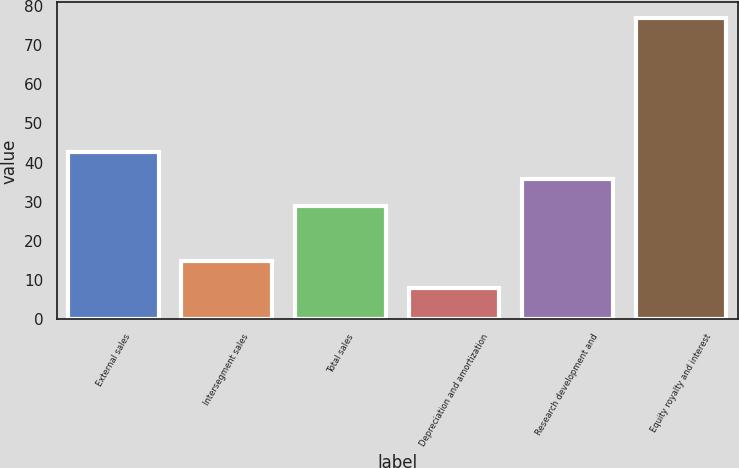Convert chart. <chart><loc_0><loc_0><loc_500><loc_500><bar_chart><fcel>External sales<fcel>Intersegment sales<fcel>Total sales<fcel>Depreciation and amortization<fcel>Research development and<fcel>Equity royalty and interest<nl><fcel>42.8<fcel>14.9<fcel>29<fcel>8<fcel>35.9<fcel>77<nl></chart> 